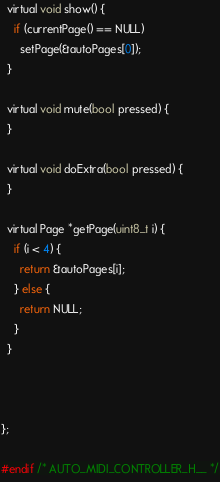Convert code to text. <code><loc_0><loc_0><loc_500><loc_500><_C_>
  virtual void show() {
    if (currentPage() == NULL)
      setPage(&autoPages[0]);
  }

  virtual void mute(bool pressed) {
  }

  virtual void doExtra(bool pressed) {
  }

  virtual Page *getPage(uint8_t i) {
    if (i < 4) {
      return &autoPages[i];
    } else {
      return NULL;
    }
  }
  
  
  
};

#endif /* AUTO_MIDI_CONTROLLER_H__ */

</code> 